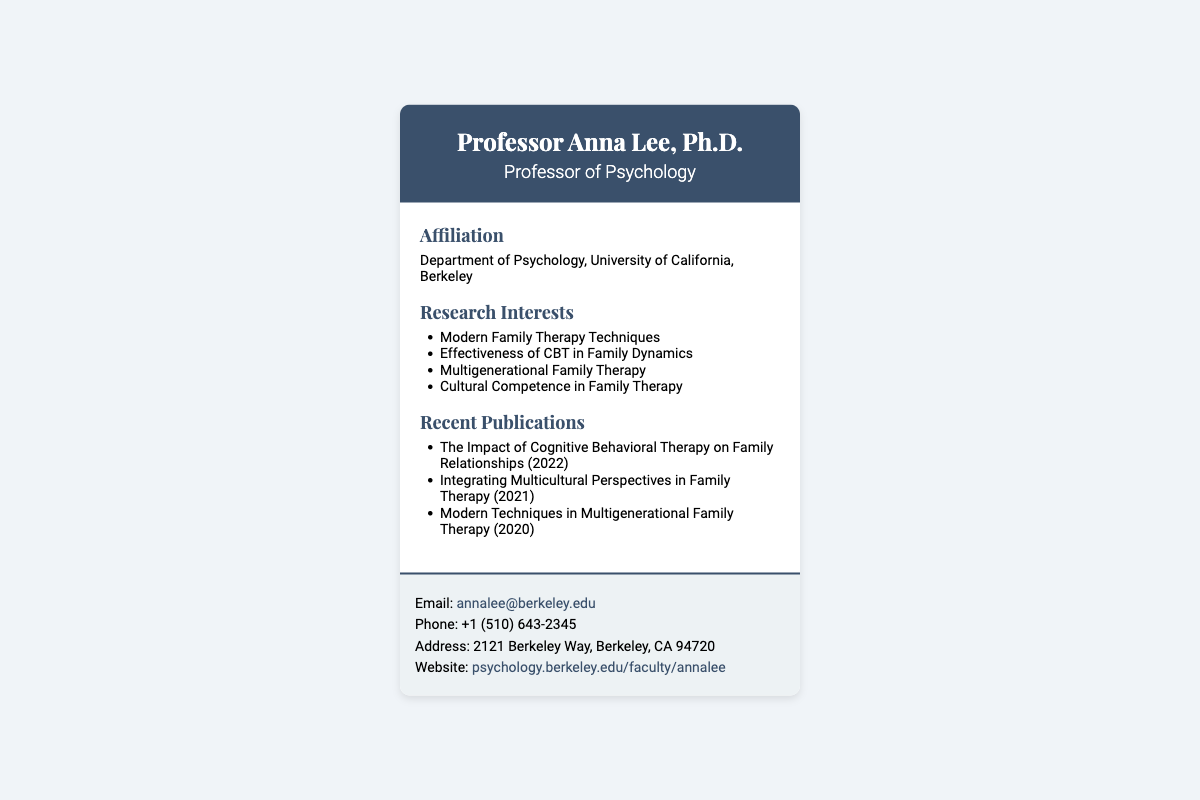What is the full title of Professor Anna Lee? The document states her title as "Professor of Psychology," indicated below her name.
Answer: Professor of Psychology Where is Professor Anna Lee affiliated? The document mentions her affiliation, which is the "Department of Psychology, University of California, Berkeley."
Answer: Department of Psychology, University of California, Berkeley What is one of Professor Lee's research interests? The list of research interests includes "Modern Family Therapy Techniques," providing specific areas of her focus.
Answer: Modern Family Therapy Techniques In what year was the publication "The Impact of Cognitive Behavioral Therapy on Family Relationships" released? The document lists this publication along with its year of release, which is 2022.
Answer: 2022 What is Professor Anna Lee's email address? The contact section provides her email address as "annalee@berkeley.edu."
Answer: annalee@berkeley.edu What type of publications does Professor Anna Lee focus on? The titles in the "Recent Publications" section indicate she focuses on family therapy topics, as seen in the listed works.
Answer: Family therapy How can one access Professor Lee's professional website? The contact section includes a website link, indicating where more information can be found about her.
Answer: psychology.berkeley.edu/faculty/annalee What is the main purpose of this document? The structured layout and information suggest it serves as a professional business card for networking and information-sharing purposes.
Answer: Business card 